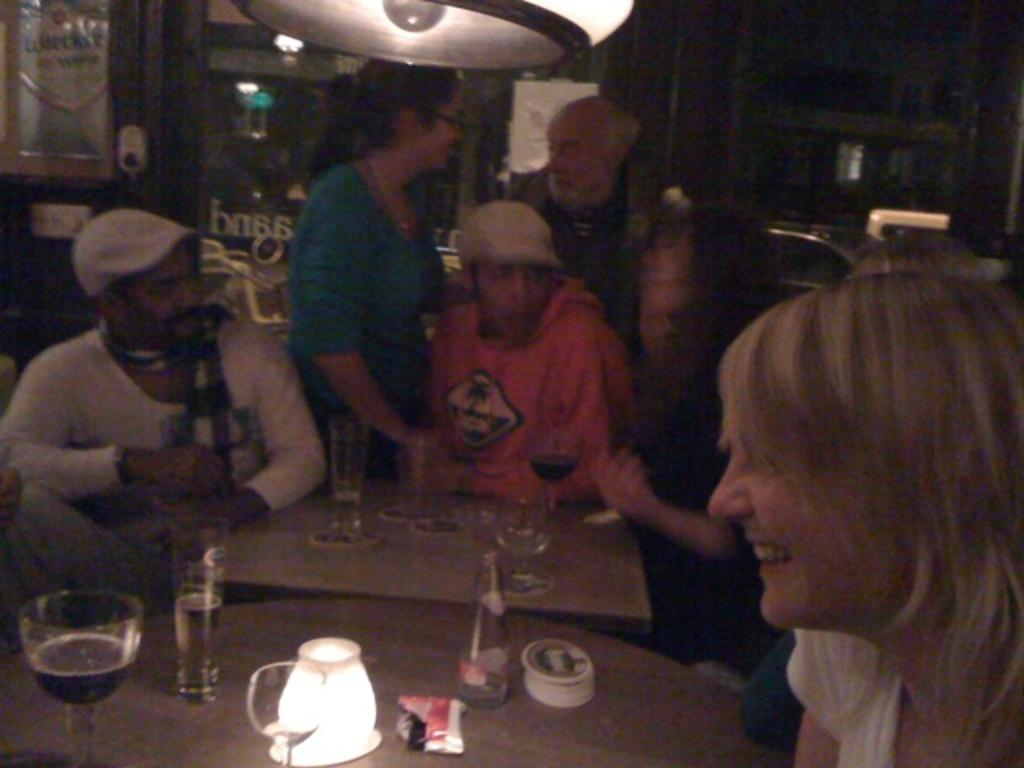What is the main activity being depicted in the image? There is a group of people sitting around a table. What can be seen on the table in the image? The table has glasses of drinks on it. Are there any other people present in the image besides those sitting at the table? Yes, there are two people standing behind the seated group. What type of bulb is hanging above the table in the image? There is no bulb present in the image; it is not mentioned in the provided facts. 